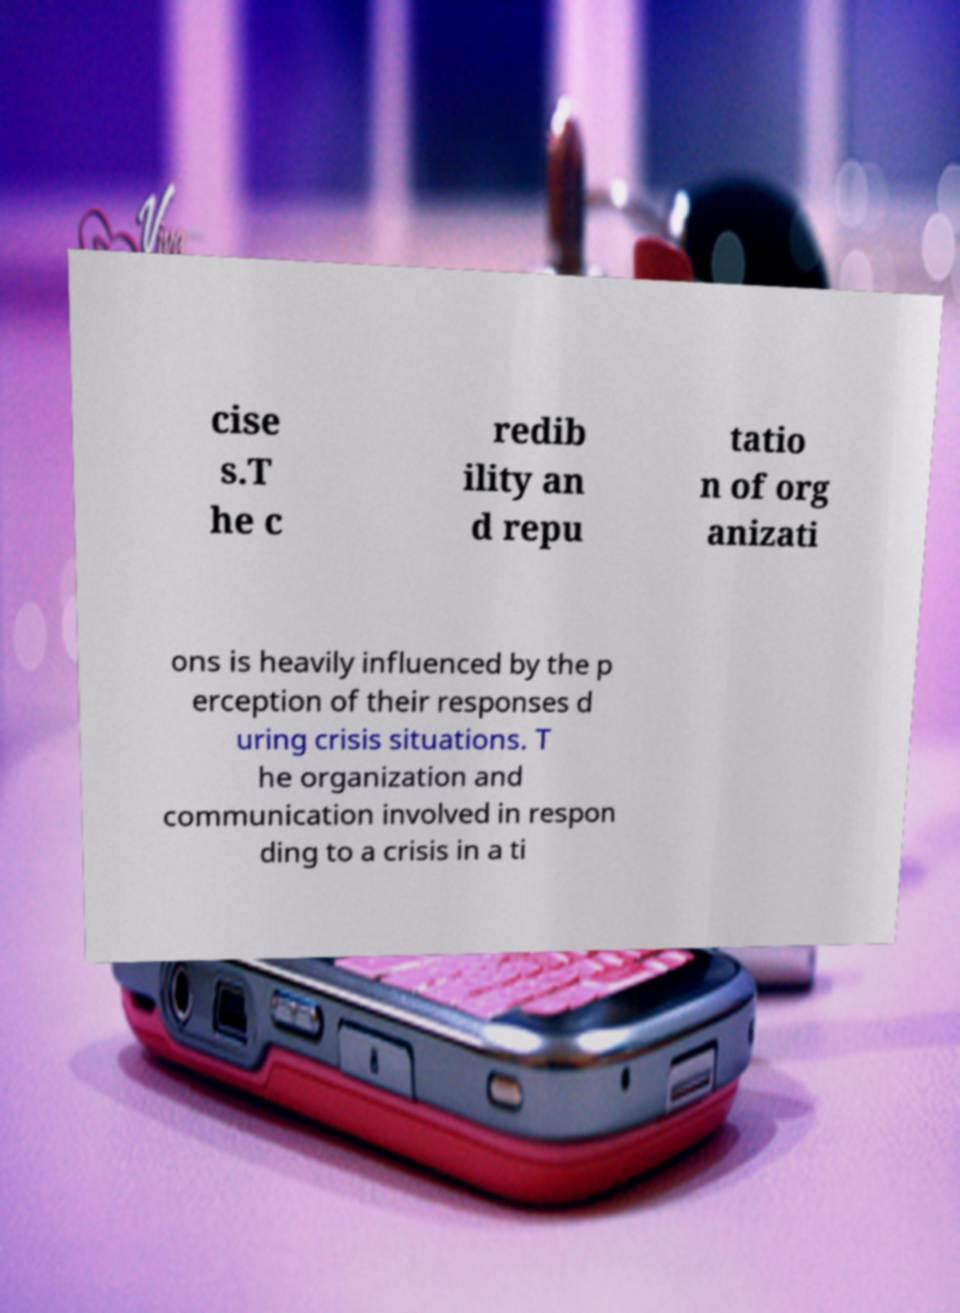Please identify and transcribe the text found in this image. cise s.T he c redib ility an d repu tatio n of org anizati ons is heavily influenced by the p erception of their responses d uring crisis situations. T he organization and communication involved in respon ding to a crisis in a ti 